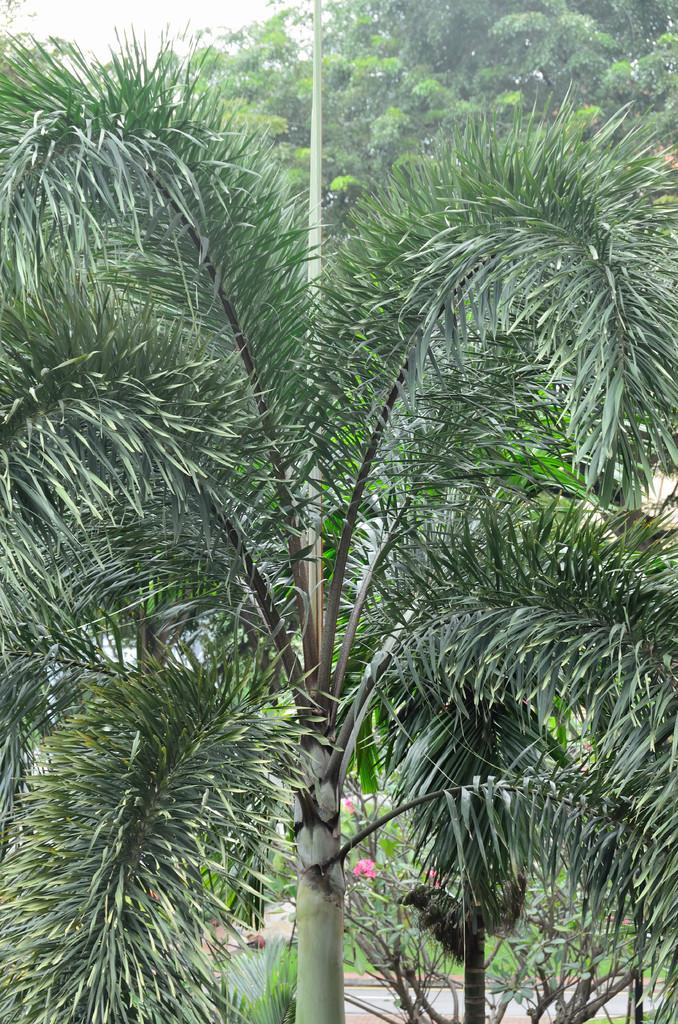What type of plant can be seen in the image? There is a tree in the image, and there are also plants visible. What is the color of the tree in the image? The tree is green in color. What other types of flora can be seen in the image? There are flowers in the image, and they are pink in color. What is visible in the background of the image? There are trees and the sky visible in the background of the image. What type of cap can be seen on the tree in the image? There is no cap present on the tree in the image. Can you tell me how many cents are visible in the image? There are no cents present in the image. 